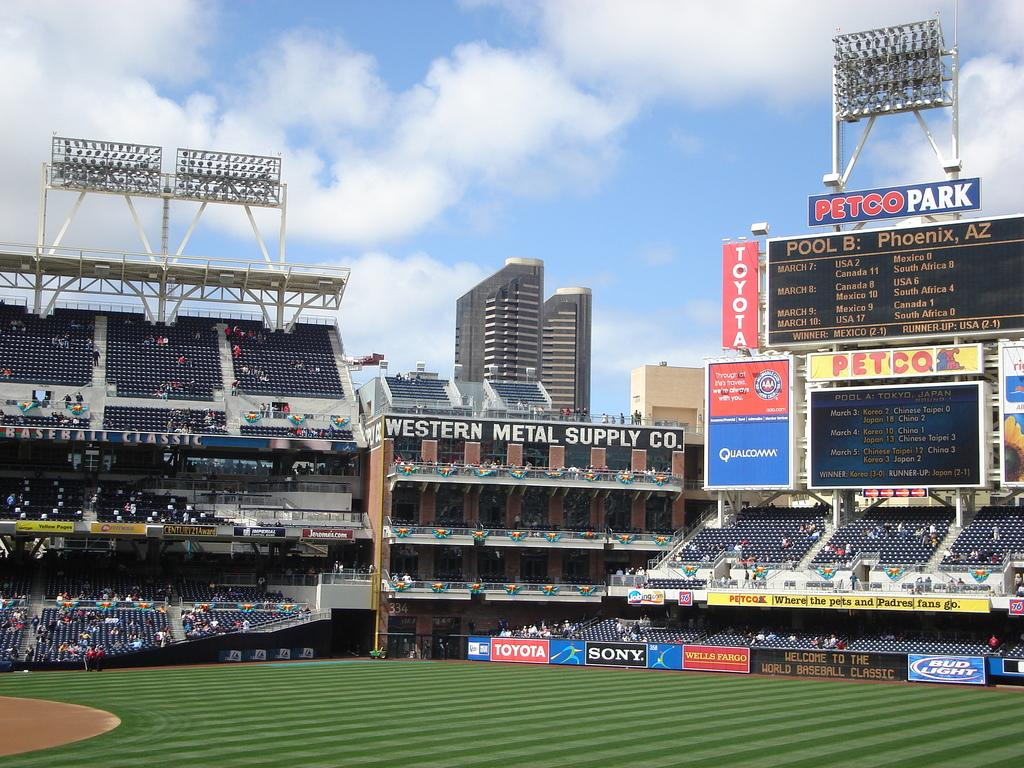<image>
Share a concise interpretation of the image provided. A photo of Petco Park with a large scoreboard. 